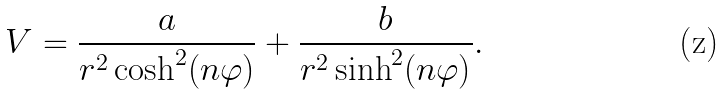<formula> <loc_0><loc_0><loc_500><loc_500>V = \frac { a } { r ^ { 2 } \cosh ^ { 2 } ( n \varphi ) } + \frac { b } { r ^ { 2 } \sinh ^ { 2 } ( n \varphi ) } .</formula> 